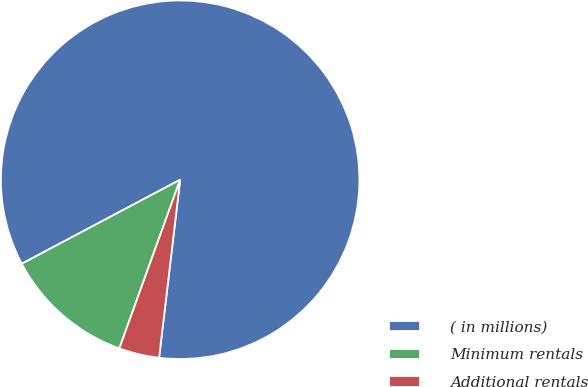Convert chart. <chart><loc_0><loc_0><loc_500><loc_500><pie_chart><fcel>( in millions)<fcel>Minimum rentals<fcel>Additional rentals<nl><fcel>84.64%<fcel>11.73%<fcel>3.63%<nl></chart> 